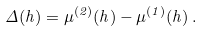Convert formula to latex. <formula><loc_0><loc_0><loc_500><loc_500>\Delta ( h ) = \mu ^ { ( 2 ) } ( h ) - \mu ^ { ( 1 ) } ( h ) \, .</formula> 